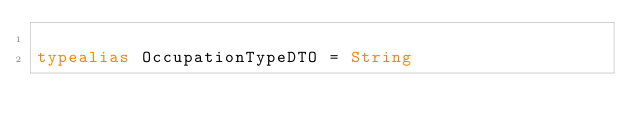Convert code to text. <code><loc_0><loc_0><loc_500><loc_500><_Kotlin_>
typealias OccupationTypeDTO = String
</code> 